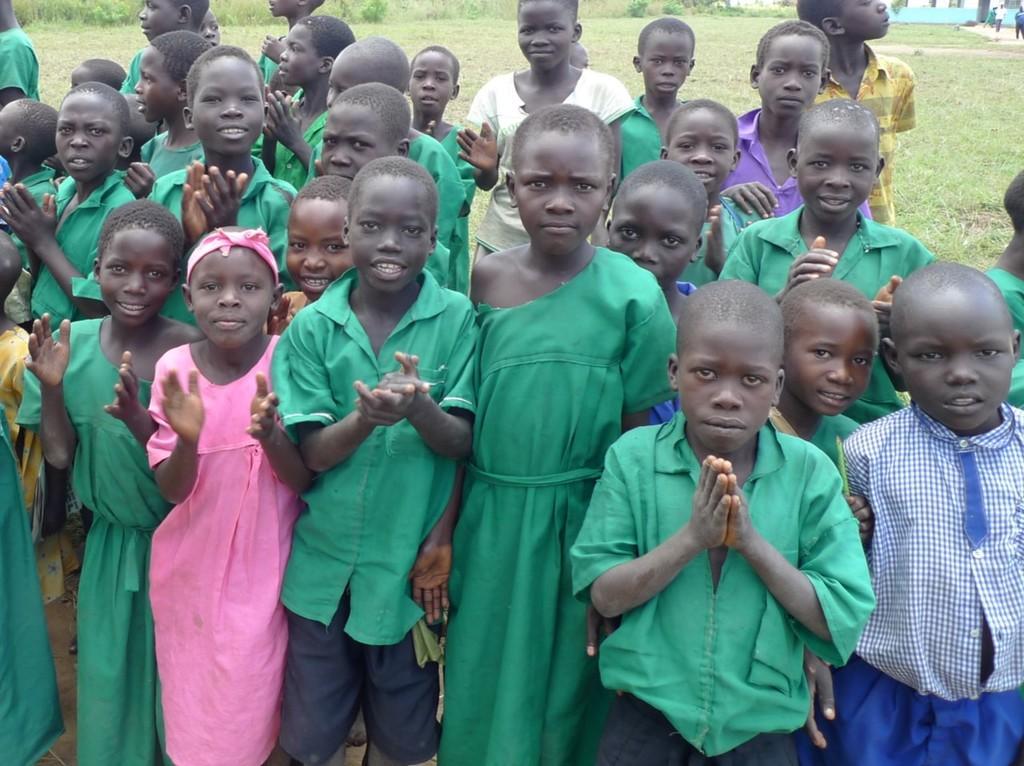Please provide a concise description of this image. In this image there are many children. In the background there is a grass, plants and building. 